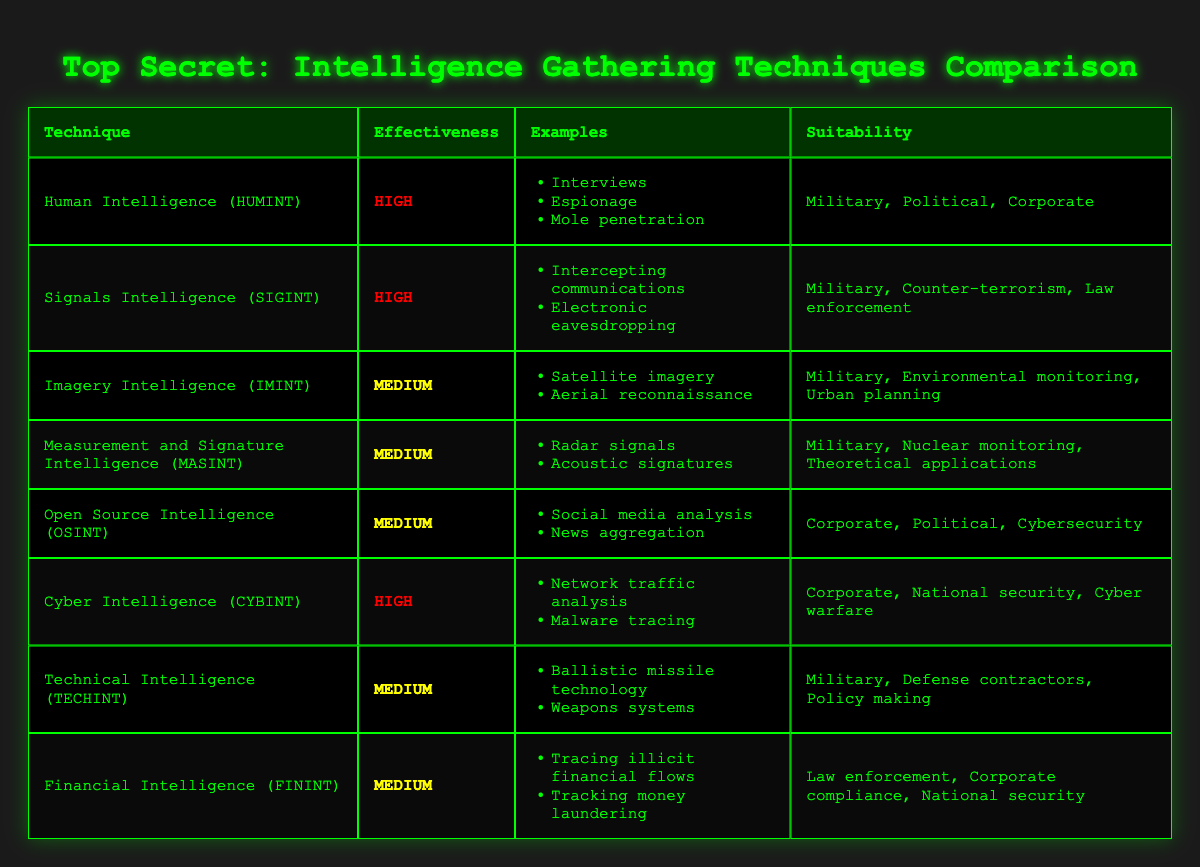What intelligence gathering technique has the highest effectiveness? The table lists the effectiveness of each technique, and both "Human Intelligence (HUMINT)" and "Signals Intelligence (SIGINT)" are marked as "High."
Answer: Human Intelligence (HUMINT), Signals Intelligence (SIGINT) Which techniques are suitable for corporate intelligence gathering? By examining the "Suitability" column, the techniques "Human Intelligence (HUMINT)," "Open Source Intelligence (OSINT)," and "Cyber Intelligence (CYBINT)" are mentioned for corporate suitability.
Answer: Human Intelligence (HUMINT), Open Source Intelligence (OSINT), Cyber Intelligence (CYBINT) What is the average effectiveness of all intelligence gathering techniques listed in the table? The effectiveness levels are High (2 techniques), Medium (5 techniques), and Low (0 techniques). To find the average, we can assign values (High=2, Medium=1, Low=0), and compute (2*2 + 5*1)/7 = 14/7 = 2 (which corresponds to Medium).
Answer: Medium Does the Financial Intelligence (FININT) technique have a high effectiveness rating? The effectiveness rating for "Financial Intelligence (FININT)" in the table is marked as "Medium." Therefore, it does not have a high effectiveness rating.
Answer: No Which techniques have a medium effectiveness rating and are suitable for military purposes? From the table, "Imagery Intelligence (IMINT)," "Measurement and Signature Intelligence (MASINT)," "Technical Intelligence (TECHINT)" all have medium effectiveness ratings and list "Military" in their suitability.
Answer: Imagery Intelligence (IMINT), Measurement and Signature Intelligence (MASINT), Technical Intelligence (TECHINT) 